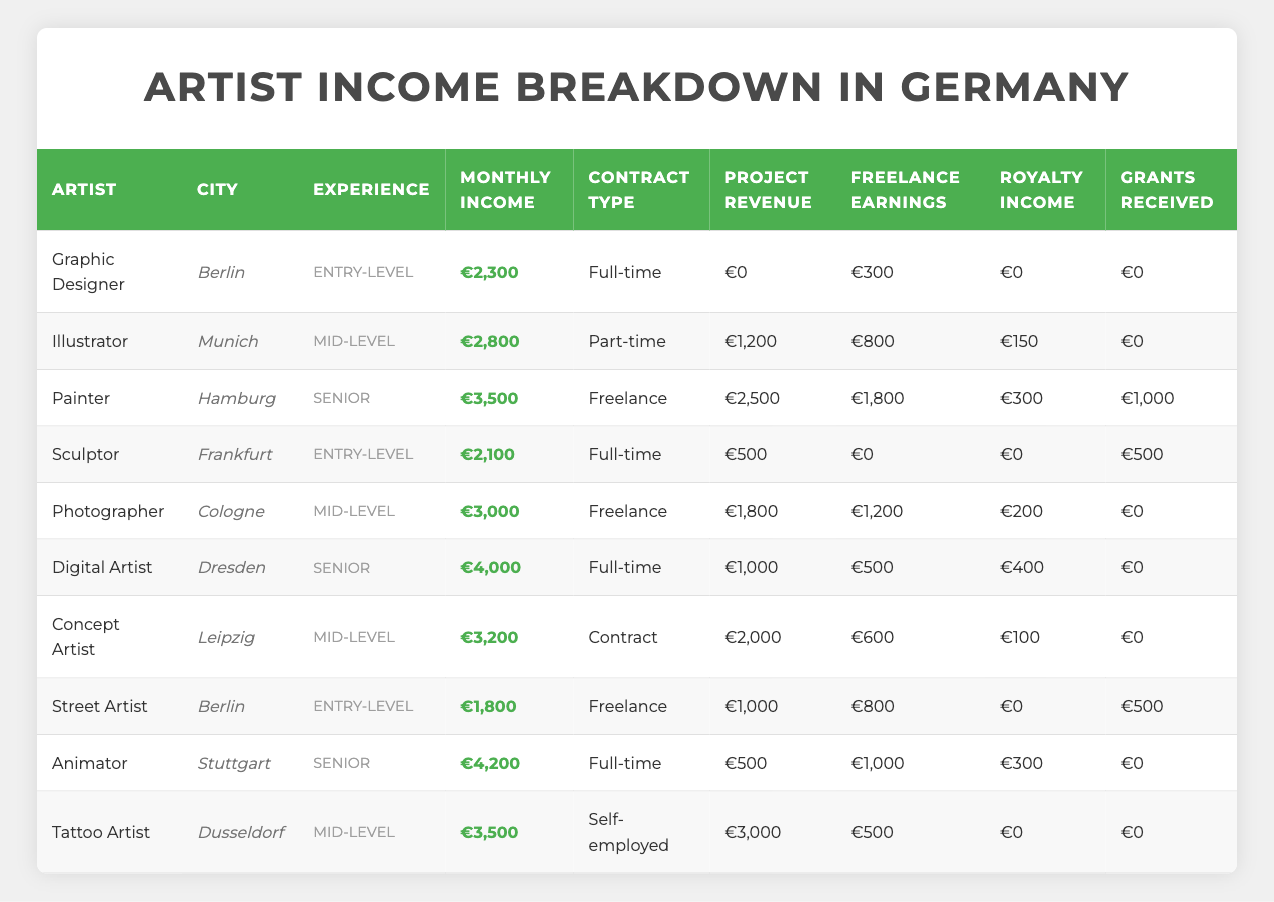What is the monthly income of the Painter in Hamburg? According to the table, the entry for the Painter shows a monthly income of €3,500.
Answer: €3,500 What type of contract does the Digital Artist from Dresden have? The Digital Artist is listed under the Contract Type as "Full-time."
Answer: Full-time Who has the highest monthly income, and how much do they earn? The table indicates that the Animator in Stuttgart has the highest monthly income, which is €4,200.
Answer: €4,200 What is the average monthly income of all artists listed in Berlin? The artists listed in Berlin are a Graphic Designer and a Street Artist. Their incomes are €2,300 and €1,800, respectively. To find the average: (2300 + 1800) / 2 = 2050.
Answer: €2,050 Is the Freelance Earnings for the Sculptor greater than the Royalty Income? The Sculptor's Freelance Earnings are €0, and their Royalty Income is also €0. Therefore, Freelance Earnings are not greater than Royalty Income.
Answer: No Which artist has the highest Project Revenue among the Mid-level experience artists? The Mid-level artists are the Illustrator, Photographer, Concept Artist, and Tattoo Artist. Their Project Revenues are €1,200, €1,800, €2,000, and €3,000, respectively. The Tattoo Artist has the highest Project Revenue of €3,000.
Answer: Tattoo Artist What percentage of the monthly income of the Animator is made up of Grants Received? The Animator's monthly income is €4,200, and they have €0 in Grants Received. To find the percentage: (0 / 4200) * 100 = 0%.
Answer: 0% Which artist has the lowest monthly income and what is it? The Street Artist in Berlin has the lowest monthly income at €1,800.
Answer: €1,800 What is the total Freelance Earnings of all artists? To find the total Freelance Earnings, we sum them up: €300 + €800 + €1,800 + €0 + €1,200 + €500 + €600 + €800 + €1,000 + €500 = €7,600.
Answer: €7,600 